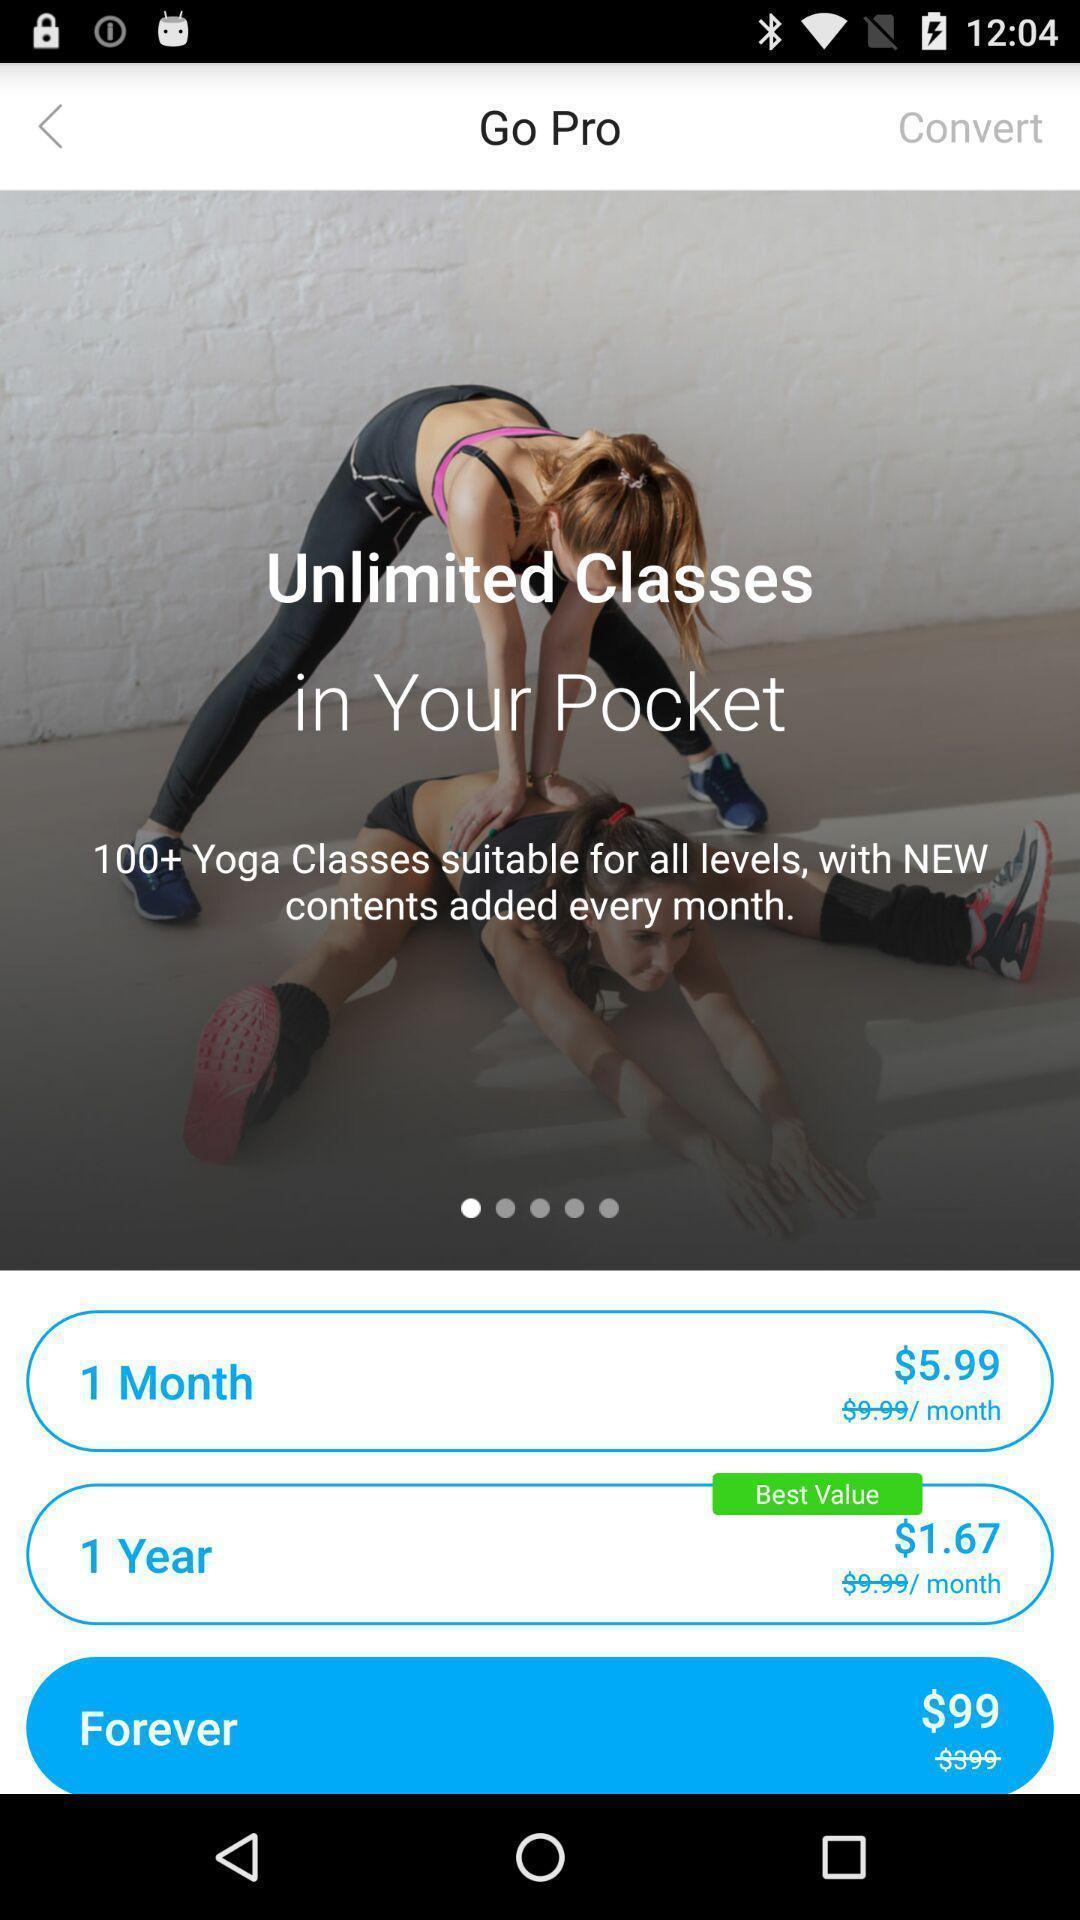Provide a detailed account of this screenshot. Welcome page showing different subscription options. 